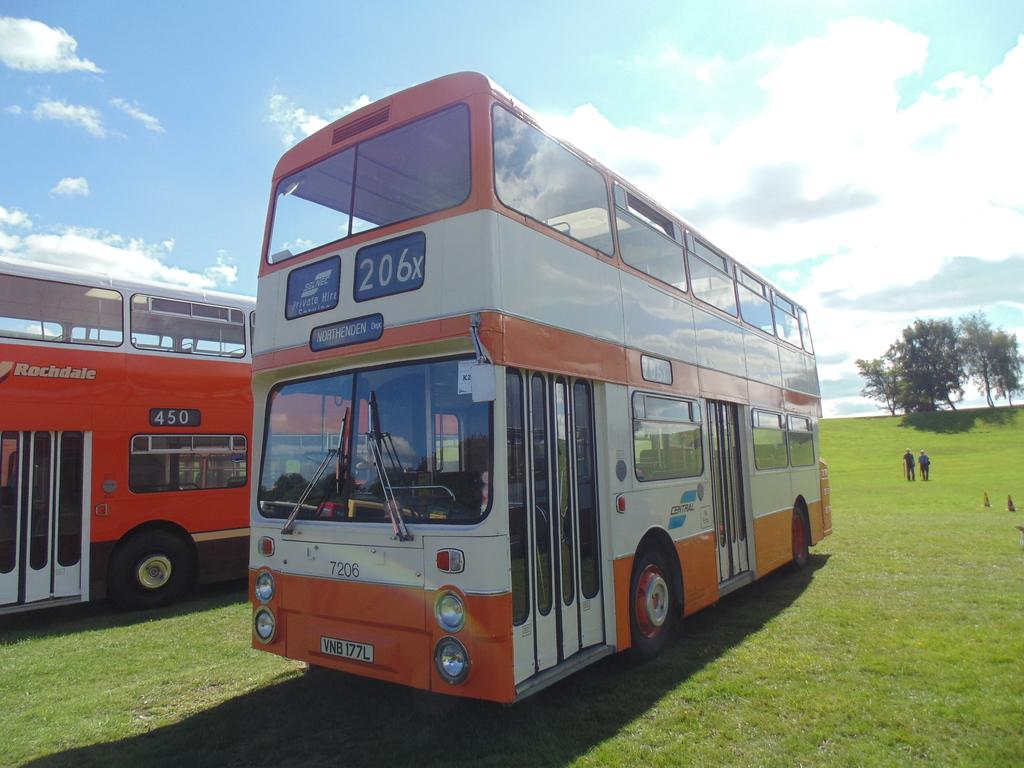What type of vehicles can be seen in the image? There are buses in the image. What type of natural environment is visible in the image? Grass, trees, and the sky are visible in the image. What objects are present to guide or direct traffic in the image? Traffic cones are present in the image. How many people are visible in the image? There are two people standing in the image. What is the condition of the sky in the image? The sky is visible in the image, and clouds are present. What type of powder is being used by the people in the image to express their anger? There is no powder or expression of anger present in the image. 